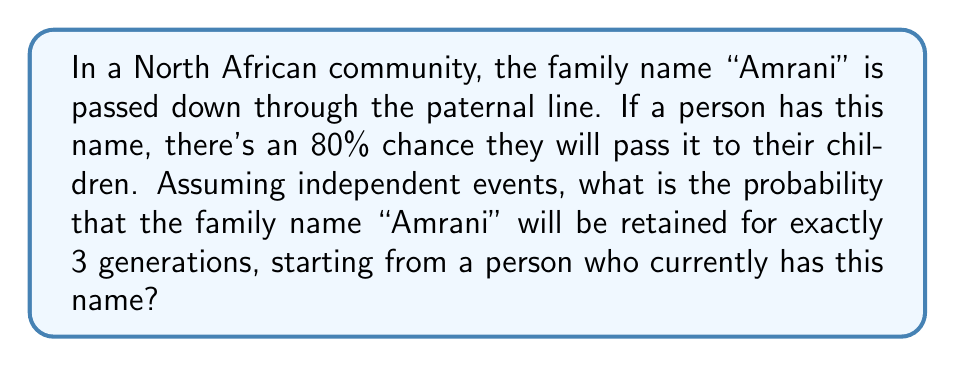Help me with this question. Let's approach this step-by-step:

1) We need the name to be passed down twice (to reach the 3rd generation) and then not passed down (to stop at exactly 3 generations).

2) The probability of passing down the name in one generation is 0.8 (80%).

3) The probability of not passing down the name in one generation is 1 - 0.8 = 0.2 (20%).

4) For exactly 3 generations, we need:
   - The name to be passed down in the 1st generation (probability 0.8)
   - The name to be passed down in the 2nd generation (probability 0.8)
   - The name to NOT be passed down in the 3rd generation (probability 0.2)

5) Since these are independent events, we multiply the probabilities:

   $$P(\text{exactly 3 generations}) = 0.8 \times 0.8 \times 0.2$$

6) Calculating:
   $$P(\text{exactly 3 generations}) = 0.8^2 \times 0.2 = 0.64 \times 0.2 = 0.128$$

Therefore, the probability of the name being retained for exactly 3 generations is 0.128 or 12.8%.
Answer: $0.128$ or $12.8\%$ 